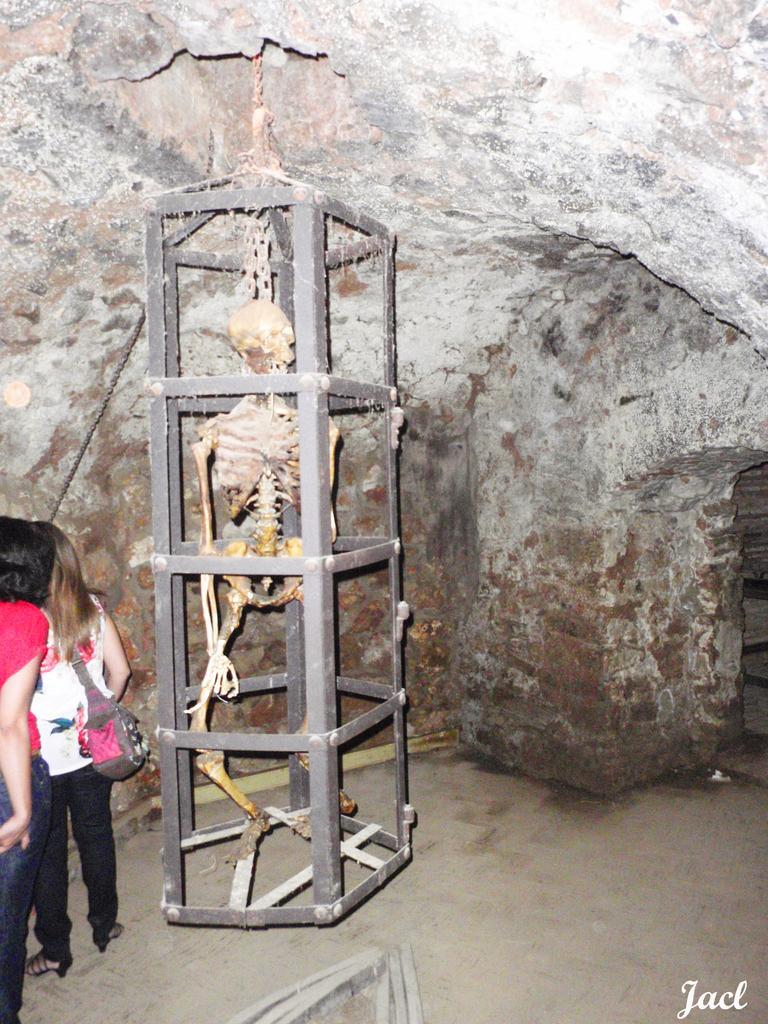Can you describe this image briefly? On the left side, there are two persons. Beside them, there is a skeleton in a cage which is attached to the roof. In the bottom right, there is a watermark. In the background, there is wall. 